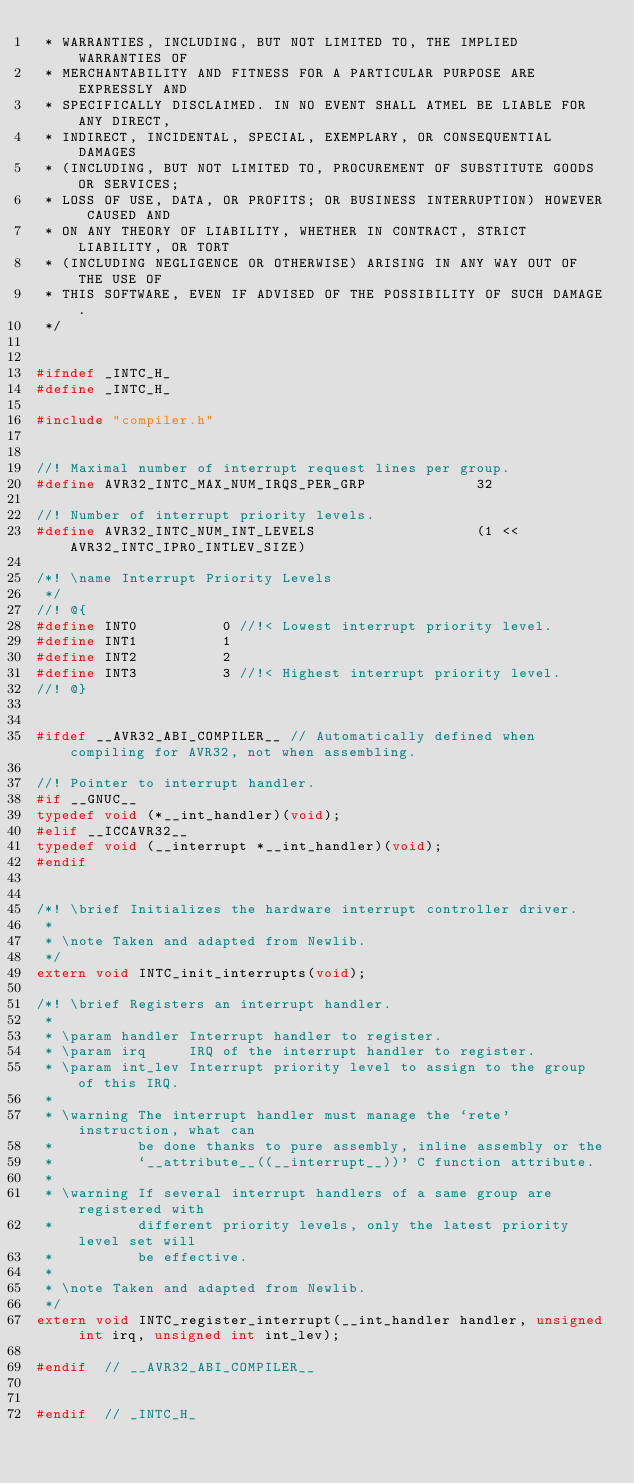<code> <loc_0><loc_0><loc_500><loc_500><_C_> * WARRANTIES, INCLUDING, BUT NOT LIMITED TO, THE IMPLIED WARRANTIES OF
 * MERCHANTABILITY AND FITNESS FOR A PARTICULAR PURPOSE ARE EXPRESSLY AND
 * SPECIFICALLY DISCLAIMED. IN NO EVENT SHALL ATMEL BE LIABLE FOR ANY DIRECT,
 * INDIRECT, INCIDENTAL, SPECIAL, EXEMPLARY, OR CONSEQUENTIAL DAMAGES
 * (INCLUDING, BUT NOT LIMITED TO, PROCUREMENT OF SUBSTITUTE GOODS OR SERVICES;
 * LOSS OF USE, DATA, OR PROFITS; OR BUSINESS INTERRUPTION) HOWEVER CAUSED AND
 * ON ANY THEORY OF LIABILITY, WHETHER IN CONTRACT, STRICT LIABILITY, OR TORT
 * (INCLUDING NEGLIGENCE OR OTHERWISE) ARISING IN ANY WAY OUT OF THE USE OF
 * THIS SOFTWARE, EVEN IF ADVISED OF THE POSSIBILITY OF SUCH DAMAGE.
 */


#ifndef _INTC_H_
#define _INTC_H_

#include "compiler.h"


//! Maximal number of interrupt request lines per group.
#define AVR32_INTC_MAX_NUM_IRQS_PER_GRP             32

//! Number of interrupt priority levels.
#define AVR32_INTC_NUM_INT_LEVELS                   (1 << AVR32_INTC_IPR0_INTLEV_SIZE)

/*! \name Interrupt Priority Levels
 */
//! @{
#define INT0          0 //!< Lowest interrupt priority level.
#define INT1          1
#define INT2          2
#define INT3          3 //!< Highest interrupt priority level.
//! @}


#ifdef __AVR32_ABI_COMPILER__ // Automatically defined when compiling for AVR32, not when assembling.

//! Pointer to interrupt handler.
#if __GNUC__
typedef void (*__int_handler)(void);
#elif __ICCAVR32__
typedef void (__interrupt *__int_handler)(void);
#endif


/*! \brief Initializes the hardware interrupt controller driver.
 *
 * \note Taken and adapted from Newlib.
 */
extern void INTC_init_interrupts(void);

/*! \brief Registers an interrupt handler.
 *
 * \param handler Interrupt handler to register.
 * \param irq     IRQ of the interrupt handler to register.
 * \param int_lev Interrupt priority level to assign to the group of this IRQ.
 *
 * \warning The interrupt handler must manage the `rete' instruction, what can
 *          be done thanks to pure assembly, inline assembly or the
 *          `__attribute__((__interrupt__))' C function attribute.
 *
 * \warning If several interrupt handlers of a same group are registered with
 *          different priority levels, only the latest priority level set will
 *          be effective.
 *
 * \note Taken and adapted from Newlib.
 */
extern void INTC_register_interrupt(__int_handler handler, unsigned int irq, unsigned int int_lev);

#endif  // __AVR32_ABI_COMPILER__


#endif  // _INTC_H_
</code> 